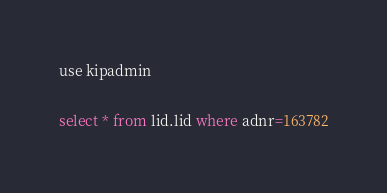<code> <loc_0><loc_0><loc_500><loc_500><_SQL_>use kipadmin

select * from lid.lid where adnr=163782</code> 